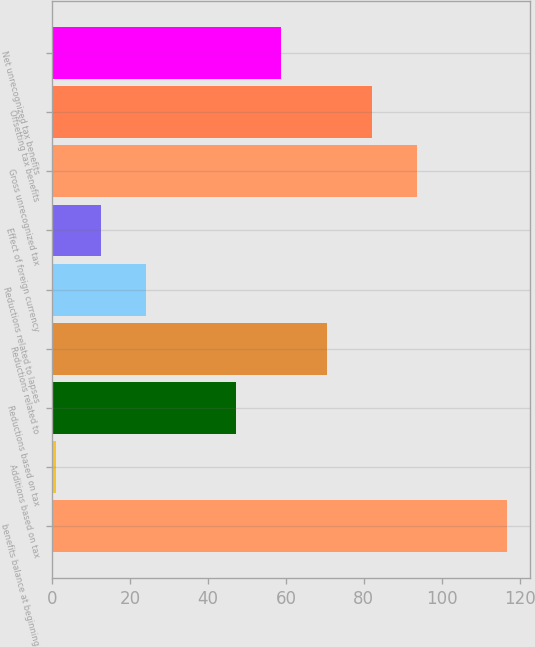<chart> <loc_0><loc_0><loc_500><loc_500><bar_chart><fcel>benefits balance at beginning<fcel>Additions based on tax<fcel>Reductions based on tax<fcel>Reductions related to<fcel>Reductions related to lapses<fcel>Effect of foreign currency<fcel>Gross unrecognized tax<fcel>Offsetting tax benefits<fcel>Net unrecognized tax benefits<nl><fcel>116.7<fcel>1<fcel>47.28<fcel>70.42<fcel>24.14<fcel>12.57<fcel>93.56<fcel>81.99<fcel>58.85<nl></chart> 